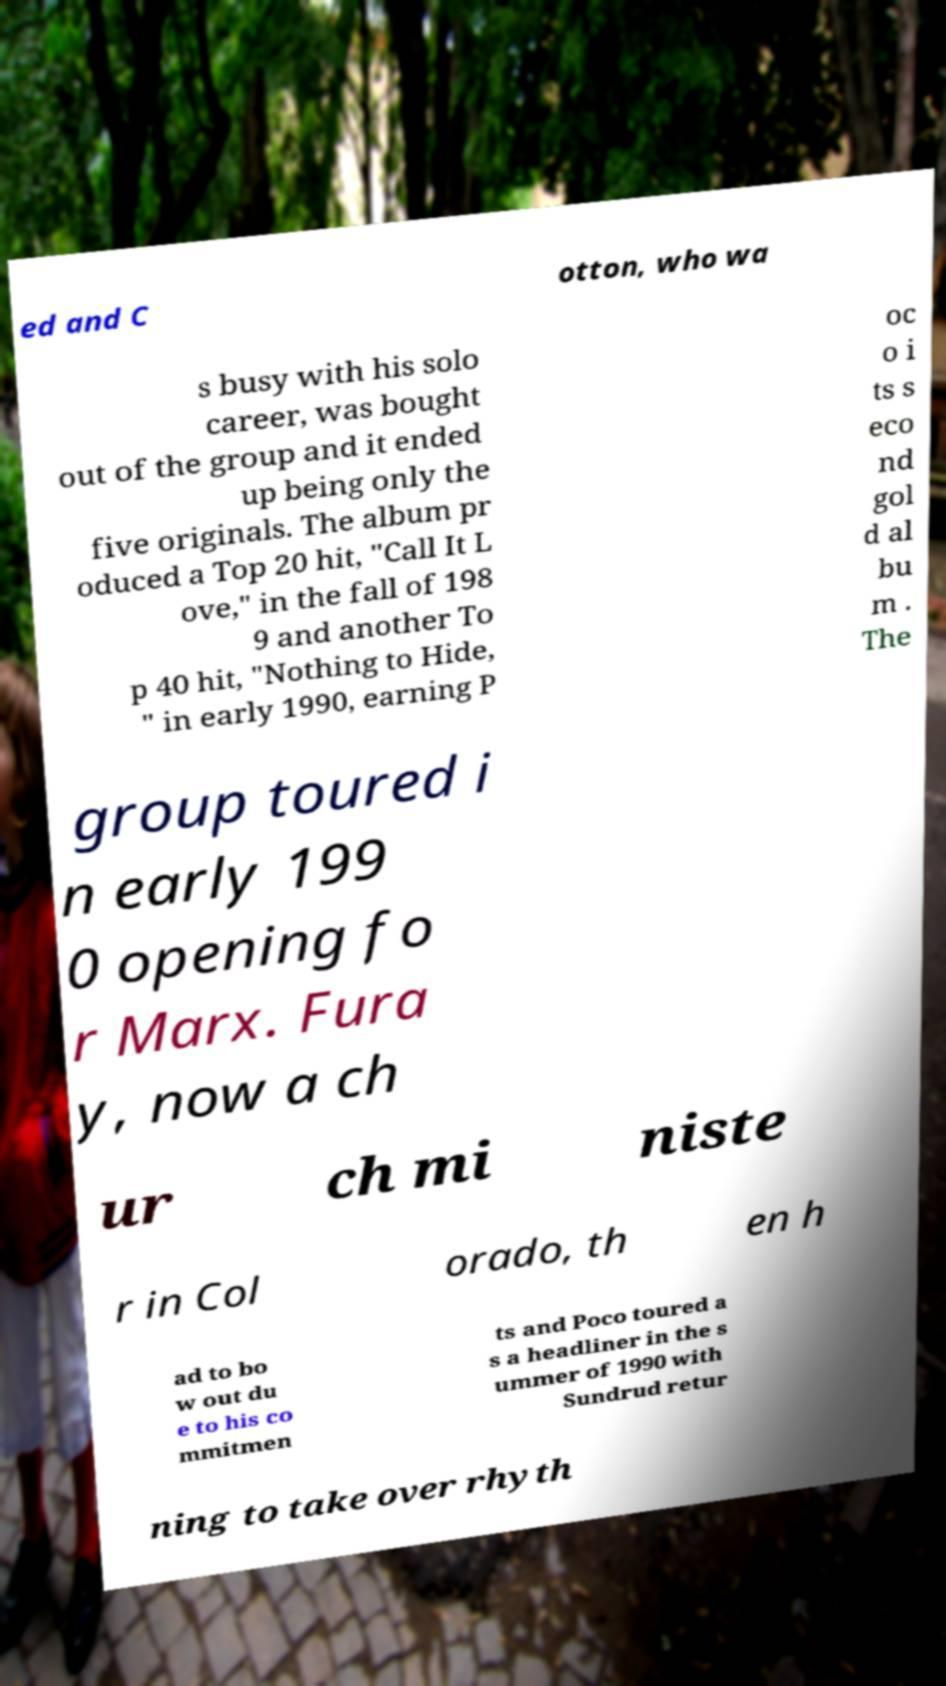Can you read and provide the text displayed in the image?This photo seems to have some interesting text. Can you extract and type it out for me? ed and C otton, who wa s busy with his solo career, was bought out of the group and it ended up being only the five originals. The album pr oduced a Top 20 hit, "Call It L ove," in the fall of 198 9 and another To p 40 hit, "Nothing to Hide, " in early 1990, earning P oc o i ts s eco nd gol d al bu m . The group toured i n early 199 0 opening fo r Marx. Fura y, now a ch ur ch mi niste r in Col orado, th en h ad to bo w out du e to his co mmitmen ts and Poco toured a s a headliner in the s ummer of 1990 with Sundrud retur ning to take over rhyth 